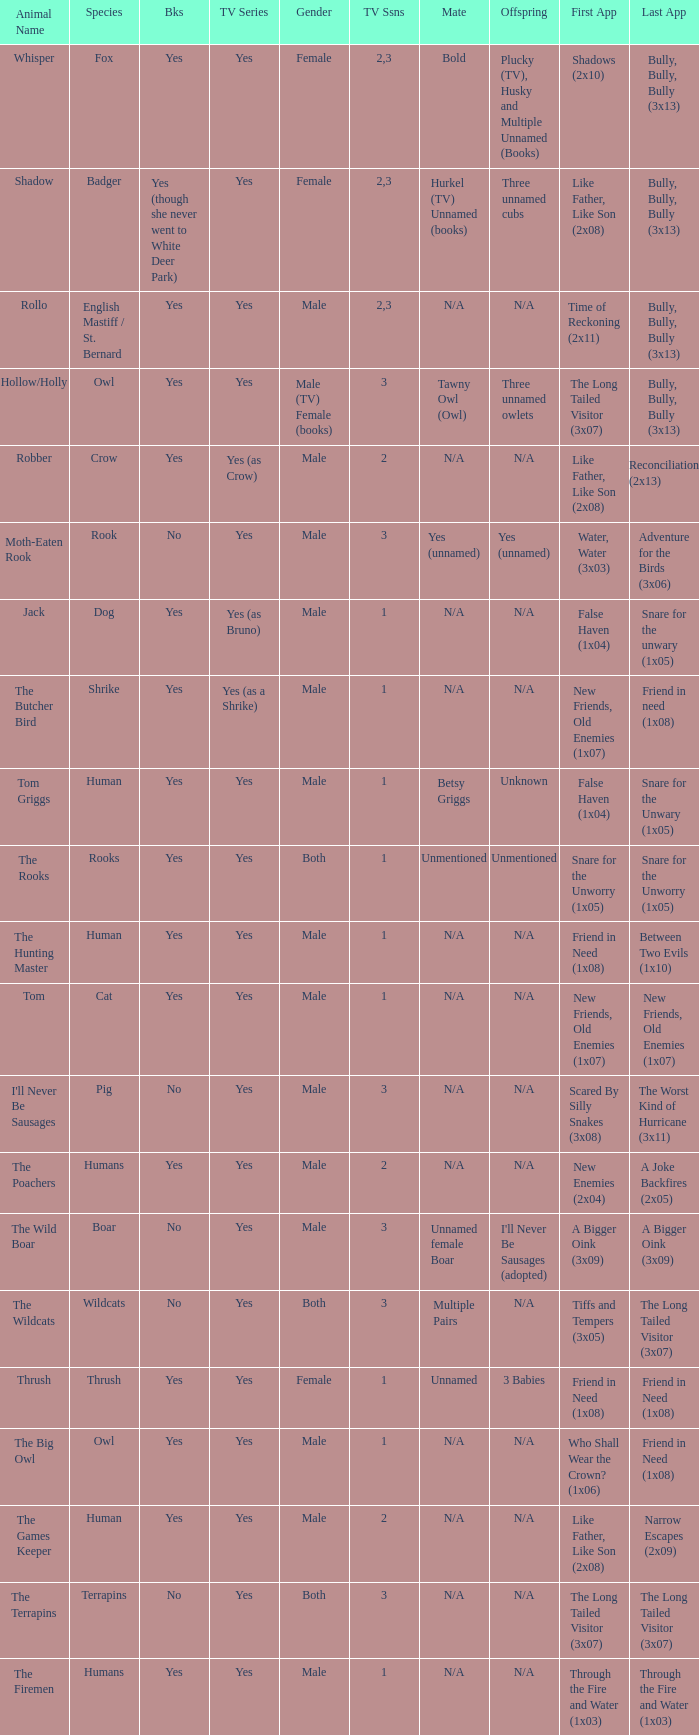Which season in a tv series involving humans and affirmative aspects has the smallest duration? 1.0. 